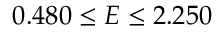<formula> <loc_0><loc_0><loc_500><loc_500>0 . 4 8 0 \leq E \leq 2 . 2 5 0</formula> 